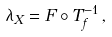<formula> <loc_0><loc_0><loc_500><loc_500>\lambda _ { X } = F \circ T _ { f } ^ { - 1 } \, ,</formula> 